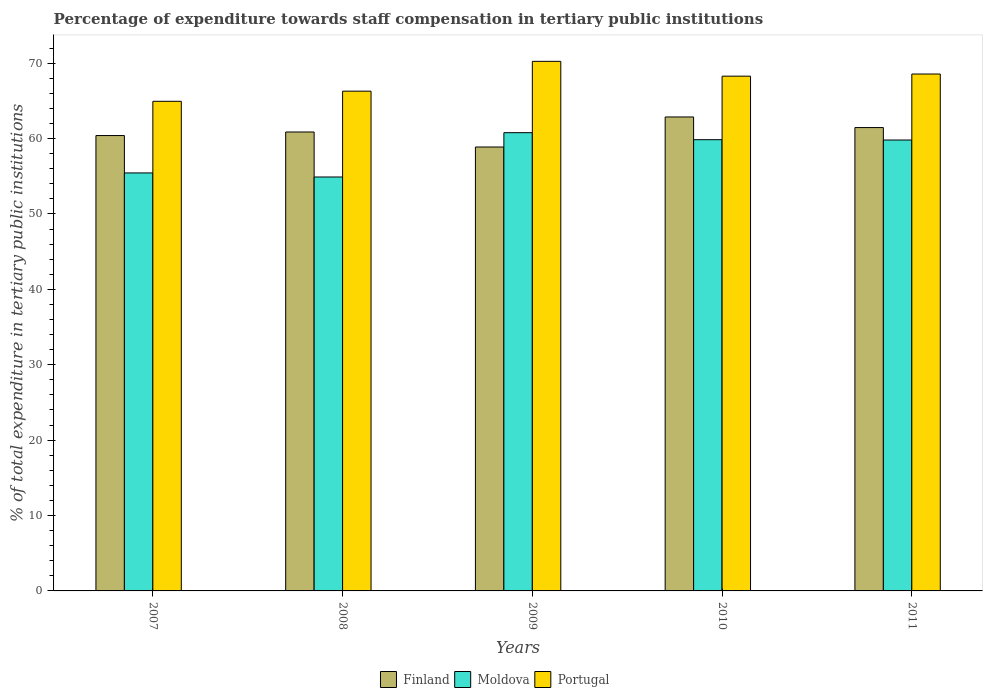How many groups of bars are there?
Offer a very short reply. 5. Are the number of bars on each tick of the X-axis equal?
Provide a short and direct response. Yes. How many bars are there on the 5th tick from the left?
Keep it short and to the point. 3. How many bars are there on the 3rd tick from the right?
Your response must be concise. 3. What is the percentage of expenditure towards staff compensation in Moldova in 2008?
Your response must be concise. 54.9. Across all years, what is the maximum percentage of expenditure towards staff compensation in Portugal?
Provide a short and direct response. 70.24. Across all years, what is the minimum percentage of expenditure towards staff compensation in Moldova?
Keep it short and to the point. 54.9. In which year was the percentage of expenditure towards staff compensation in Moldova maximum?
Your answer should be compact. 2009. In which year was the percentage of expenditure towards staff compensation in Finland minimum?
Keep it short and to the point. 2009. What is the total percentage of expenditure towards staff compensation in Moldova in the graph?
Offer a terse response. 290.76. What is the difference between the percentage of expenditure towards staff compensation in Portugal in 2008 and that in 2009?
Your response must be concise. -3.95. What is the difference between the percentage of expenditure towards staff compensation in Finland in 2008 and the percentage of expenditure towards staff compensation in Moldova in 2011?
Provide a succinct answer. 1.07. What is the average percentage of expenditure towards staff compensation in Finland per year?
Your answer should be compact. 60.89. In the year 2010, what is the difference between the percentage of expenditure towards staff compensation in Finland and percentage of expenditure towards staff compensation in Moldova?
Ensure brevity in your answer.  3.01. What is the ratio of the percentage of expenditure towards staff compensation in Finland in 2007 to that in 2008?
Provide a short and direct response. 0.99. What is the difference between the highest and the second highest percentage of expenditure towards staff compensation in Moldova?
Keep it short and to the point. 0.93. What is the difference between the highest and the lowest percentage of expenditure towards staff compensation in Portugal?
Offer a very short reply. 5.3. In how many years, is the percentage of expenditure towards staff compensation in Finland greater than the average percentage of expenditure towards staff compensation in Finland taken over all years?
Offer a very short reply. 2. Is the sum of the percentage of expenditure towards staff compensation in Moldova in 2008 and 2011 greater than the maximum percentage of expenditure towards staff compensation in Finland across all years?
Offer a very short reply. Yes. What does the 1st bar from the left in 2007 represents?
Your answer should be very brief. Finland. What does the 2nd bar from the right in 2011 represents?
Offer a very short reply. Moldova. How many bars are there?
Ensure brevity in your answer.  15. Are the values on the major ticks of Y-axis written in scientific E-notation?
Your answer should be compact. No. Does the graph contain any zero values?
Keep it short and to the point. No. Does the graph contain grids?
Your answer should be very brief. No. Where does the legend appear in the graph?
Provide a succinct answer. Bottom center. How many legend labels are there?
Your answer should be very brief. 3. What is the title of the graph?
Your response must be concise. Percentage of expenditure towards staff compensation in tertiary public institutions. What is the label or title of the X-axis?
Provide a short and direct response. Years. What is the label or title of the Y-axis?
Provide a succinct answer. % of total expenditure in tertiary public institutions. What is the % of total expenditure in tertiary public institutions in Finland in 2007?
Provide a short and direct response. 60.39. What is the % of total expenditure in tertiary public institutions of Moldova in 2007?
Your answer should be compact. 55.44. What is the % of total expenditure in tertiary public institutions of Portugal in 2007?
Your response must be concise. 64.94. What is the % of total expenditure in tertiary public institutions of Finland in 2008?
Provide a short and direct response. 60.87. What is the % of total expenditure in tertiary public institutions in Moldova in 2008?
Offer a terse response. 54.9. What is the % of total expenditure in tertiary public institutions of Portugal in 2008?
Provide a short and direct response. 66.28. What is the % of total expenditure in tertiary public institutions in Finland in 2009?
Your response must be concise. 58.88. What is the % of total expenditure in tertiary public institutions of Moldova in 2009?
Your answer should be compact. 60.78. What is the % of total expenditure in tertiary public institutions in Portugal in 2009?
Your answer should be very brief. 70.24. What is the % of total expenditure in tertiary public institutions in Finland in 2010?
Make the answer very short. 62.86. What is the % of total expenditure in tertiary public institutions in Moldova in 2010?
Ensure brevity in your answer.  59.85. What is the % of total expenditure in tertiary public institutions in Portugal in 2010?
Offer a very short reply. 68.27. What is the % of total expenditure in tertiary public institutions of Finland in 2011?
Keep it short and to the point. 61.45. What is the % of total expenditure in tertiary public institutions of Moldova in 2011?
Your response must be concise. 59.8. What is the % of total expenditure in tertiary public institutions of Portugal in 2011?
Offer a terse response. 68.56. Across all years, what is the maximum % of total expenditure in tertiary public institutions in Finland?
Offer a very short reply. 62.86. Across all years, what is the maximum % of total expenditure in tertiary public institutions in Moldova?
Offer a terse response. 60.78. Across all years, what is the maximum % of total expenditure in tertiary public institutions of Portugal?
Make the answer very short. 70.24. Across all years, what is the minimum % of total expenditure in tertiary public institutions in Finland?
Offer a very short reply. 58.88. Across all years, what is the minimum % of total expenditure in tertiary public institutions of Moldova?
Keep it short and to the point. 54.9. Across all years, what is the minimum % of total expenditure in tertiary public institutions in Portugal?
Offer a very short reply. 64.94. What is the total % of total expenditure in tertiary public institutions of Finland in the graph?
Offer a very short reply. 304.45. What is the total % of total expenditure in tertiary public institutions in Moldova in the graph?
Your answer should be compact. 290.76. What is the total % of total expenditure in tertiary public institutions in Portugal in the graph?
Keep it short and to the point. 338.28. What is the difference between the % of total expenditure in tertiary public institutions of Finland in 2007 and that in 2008?
Your response must be concise. -0.47. What is the difference between the % of total expenditure in tertiary public institutions in Moldova in 2007 and that in 2008?
Offer a very short reply. 0.54. What is the difference between the % of total expenditure in tertiary public institutions in Portugal in 2007 and that in 2008?
Your answer should be very brief. -1.35. What is the difference between the % of total expenditure in tertiary public institutions in Finland in 2007 and that in 2009?
Your answer should be compact. 1.52. What is the difference between the % of total expenditure in tertiary public institutions in Moldova in 2007 and that in 2009?
Provide a short and direct response. -5.34. What is the difference between the % of total expenditure in tertiary public institutions of Portugal in 2007 and that in 2009?
Offer a very short reply. -5.3. What is the difference between the % of total expenditure in tertiary public institutions of Finland in 2007 and that in 2010?
Your response must be concise. -2.47. What is the difference between the % of total expenditure in tertiary public institutions of Moldova in 2007 and that in 2010?
Make the answer very short. -4.41. What is the difference between the % of total expenditure in tertiary public institutions in Portugal in 2007 and that in 2010?
Your response must be concise. -3.33. What is the difference between the % of total expenditure in tertiary public institutions in Finland in 2007 and that in 2011?
Offer a terse response. -1.06. What is the difference between the % of total expenditure in tertiary public institutions of Moldova in 2007 and that in 2011?
Your answer should be very brief. -4.36. What is the difference between the % of total expenditure in tertiary public institutions of Portugal in 2007 and that in 2011?
Provide a succinct answer. -3.62. What is the difference between the % of total expenditure in tertiary public institutions of Finland in 2008 and that in 2009?
Your answer should be very brief. 1.99. What is the difference between the % of total expenditure in tertiary public institutions of Moldova in 2008 and that in 2009?
Your answer should be very brief. -5.88. What is the difference between the % of total expenditure in tertiary public institutions in Portugal in 2008 and that in 2009?
Your answer should be very brief. -3.95. What is the difference between the % of total expenditure in tertiary public institutions in Finland in 2008 and that in 2010?
Provide a succinct answer. -1.99. What is the difference between the % of total expenditure in tertiary public institutions of Moldova in 2008 and that in 2010?
Offer a very short reply. -4.95. What is the difference between the % of total expenditure in tertiary public institutions of Portugal in 2008 and that in 2010?
Offer a very short reply. -1.99. What is the difference between the % of total expenditure in tertiary public institutions of Finland in 2008 and that in 2011?
Provide a short and direct response. -0.59. What is the difference between the % of total expenditure in tertiary public institutions of Moldova in 2008 and that in 2011?
Provide a short and direct response. -4.9. What is the difference between the % of total expenditure in tertiary public institutions in Portugal in 2008 and that in 2011?
Provide a succinct answer. -2.27. What is the difference between the % of total expenditure in tertiary public institutions in Finland in 2009 and that in 2010?
Your answer should be compact. -3.98. What is the difference between the % of total expenditure in tertiary public institutions in Moldova in 2009 and that in 2010?
Provide a short and direct response. 0.93. What is the difference between the % of total expenditure in tertiary public institutions of Portugal in 2009 and that in 2010?
Offer a terse response. 1.96. What is the difference between the % of total expenditure in tertiary public institutions of Finland in 2009 and that in 2011?
Provide a short and direct response. -2.58. What is the difference between the % of total expenditure in tertiary public institutions of Moldova in 2009 and that in 2011?
Provide a succinct answer. 0.98. What is the difference between the % of total expenditure in tertiary public institutions of Portugal in 2009 and that in 2011?
Your answer should be very brief. 1.68. What is the difference between the % of total expenditure in tertiary public institutions of Finland in 2010 and that in 2011?
Provide a succinct answer. 1.41. What is the difference between the % of total expenditure in tertiary public institutions in Moldova in 2010 and that in 2011?
Your answer should be compact. 0.04. What is the difference between the % of total expenditure in tertiary public institutions in Portugal in 2010 and that in 2011?
Offer a very short reply. -0.28. What is the difference between the % of total expenditure in tertiary public institutions of Finland in 2007 and the % of total expenditure in tertiary public institutions of Moldova in 2008?
Make the answer very short. 5.5. What is the difference between the % of total expenditure in tertiary public institutions of Finland in 2007 and the % of total expenditure in tertiary public institutions of Portugal in 2008?
Your answer should be compact. -5.89. What is the difference between the % of total expenditure in tertiary public institutions of Moldova in 2007 and the % of total expenditure in tertiary public institutions of Portugal in 2008?
Your answer should be very brief. -10.85. What is the difference between the % of total expenditure in tertiary public institutions of Finland in 2007 and the % of total expenditure in tertiary public institutions of Moldova in 2009?
Give a very brief answer. -0.38. What is the difference between the % of total expenditure in tertiary public institutions of Finland in 2007 and the % of total expenditure in tertiary public institutions of Portugal in 2009?
Your answer should be very brief. -9.84. What is the difference between the % of total expenditure in tertiary public institutions in Moldova in 2007 and the % of total expenditure in tertiary public institutions in Portugal in 2009?
Provide a short and direct response. -14.8. What is the difference between the % of total expenditure in tertiary public institutions of Finland in 2007 and the % of total expenditure in tertiary public institutions of Moldova in 2010?
Offer a very short reply. 0.55. What is the difference between the % of total expenditure in tertiary public institutions of Finland in 2007 and the % of total expenditure in tertiary public institutions of Portugal in 2010?
Offer a terse response. -7.88. What is the difference between the % of total expenditure in tertiary public institutions in Moldova in 2007 and the % of total expenditure in tertiary public institutions in Portugal in 2010?
Your answer should be compact. -12.83. What is the difference between the % of total expenditure in tertiary public institutions of Finland in 2007 and the % of total expenditure in tertiary public institutions of Moldova in 2011?
Provide a succinct answer. 0.59. What is the difference between the % of total expenditure in tertiary public institutions in Finland in 2007 and the % of total expenditure in tertiary public institutions in Portugal in 2011?
Give a very brief answer. -8.16. What is the difference between the % of total expenditure in tertiary public institutions of Moldova in 2007 and the % of total expenditure in tertiary public institutions of Portugal in 2011?
Provide a short and direct response. -13.12. What is the difference between the % of total expenditure in tertiary public institutions in Finland in 2008 and the % of total expenditure in tertiary public institutions in Moldova in 2009?
Make the answer very short. 0.09. What is the difference between the % of total expenditure in tertiary public institutions in Finland in 2008 and the % of total expenditure in tertiary public institutions in Portugal in 2009?
Make the answer very short. -9.37. What is the difference between the % of total expenditure in tertiary public institutions of Moldova in 2008 and the % of total expenditure in tertiary public institutions of Portugal in 2009?
Make the answer very short. -15.34. What is the difference between the % of total expenditure in tertiary public institutions of Finland in 2008 and the % of total expenditure in tertiary public institutions of Moldova in 2010?
Your answer should be very brief. 1.02. What is the difference between the % of total expenditure in tertiary public institutions of Finland in 2008 and the % of total expenditure in tertiary public institutions of Portugal in 2010?
Provide a short and direct response. -7.4. What is the difference between the % of total expenditure in tertiary public institutions in Moldova in 2008 and the % of total expenditure in tertiary public institutions in Portugal in 2010?
Provide a short and direct response. -13.37. What is the difference between the % of total expenditure in tertiary public institutions in Finland in 2008 and the % of total expenditure in tertiary public institutions in Moldova in 2011?
Make the answer very short. 1.07. What is the difference between the % of total expenditure in tertiary public institutions of Finland in 2008 and the % of total expenditure in tertiary public institutions of Portugal in 2011?
Your response must be concise. -7.69. What is the difference between the % of total expenditure in tertiary public institutions in Moldova in 2008 and the % of total expenditure in tertiary public institutions in Portugal in 2011?
Keep it short and to the point. -13.66. What is the difference between the % of total expenditure in tertiary public institutions of Finland in 2009 and the % of total expenditure in tertiary public institutions of Moldova in 2010?
Offer a terse response. -0.97. What is the difference between the % of total expenditure in tertiary public institutions of Finland in 2009 and the % of total expenditure in tertiary public institutions of Portugal in 2010?
Ensure brevity in your answer.  -9.4. What is the difference between the % of total expenditure in tertiary public institutions of Moldova in 2009 and the % of total expenditure in tertiary public institutions of Portugal in 2010?
Your response must be concise. -7.49. What is the difference between the % of total expenditure in tertiary public institutions in Finland in 2009 and the % of total expenditure in tertiary public institutions in Moldova in 2011?
Give a very brief answer. -0.92. What is the difference between the % of total expenditure in tertiary public institutions in Finland in 2009 and the % of total expenditure in tertiary public institutions in Portugal in 2011?
Keep it short and to the point. -9.68. What is the difference between the % of total expenditure in tertiary public institutions of Moldova in 2009 and the % of total expenditure in tertiary public institutions of Portugal in 2011?
Your answer should be compact. -7.78. What is the difference between the % of total expenditure in tertiary public institutions in Finland in 2010 and the % of total expenditure in tertiary public institutions in Moldova in 2011?
Offer a very short reply. 3.06. What is the difference between the % of total expenditure in tertiary public institutions in Finland in 2010 and the % of total expenditure in tertiary public institutions in Portugal in 2011?
Offer a terse response. -5.7. What is the difference between the % of total expenditure in tertiary public institutions of Moldova in 2010 and the % of total expenditure in tertiary public institutions of Portugal in 2011?
Your answer should be very brief. -8.71. What is the average % of total expenditure in tertiary public institutions in Finland per year?
Your answer should be compact. 60.89. What is the average % of total expenditure in tertiary public institutions of Moldova per year?
Offer a terse response. 58.15. What is the average % of total expenditure in tertiary public institutions of Portugal per year?
Keep it short and to the point. 67.66. In the year 2007, what is the difference between the % of total expenditure in tertiary public institutions in Finland and % of total expenditure in tertiary public institutions in Moldova?
Ensure brevity in your answer.  4.96. In the year 2007, what is the difference between the % of total expenditure in tertiary public institutions in Finland and % of total expenditure in tertiary public institutions in Portugal?
Your response must be concise. -4.54. In the year 2007, what is the difference between the % of total expenditure in tertiary public institutions of Moldova and % of total expenditure in tertiary public institutions of Portugal?
Your answer should be very brief. -9.5. In the year 2008, what is the difference between the % of total expenditure in tertiary public institutions of Finland and % of total expenditure in tertiary public institutions of Moldova?
Your response must be concise. 5.97. In the year 2008, what is the difference between the % of total expenditure in tertiary public institutions of Finland and % of total expenditure in tertiary public institutions of Portugal?
Your response must be concise. -5.42. In the year 2008, what is the difference between the % of total expenditure in tertiary public institutions in Moldova and % of total expenditure in tertiary public institutions in Portugal?
Your answer should be compact. -11.38. In the year 2009, what is the difference between the % of total expenditure in tertiary public institutions in Finland and % of total expenditure in tertiary public institutions in Moldova?
Your response must be concise. -1.9. In the year 2009, what is the difference between the % of total expenditure in tertiary public institutions of Finland and % of total expenditure in tertiary public institutions of Portugal?
Make the answer very short. -11.36. In the year 2009, what is the difference between the % of total expenditure in tertiary public institutions in Moldova and % of total expenditure in tertiary public institutions in Portugal?
Your answer should be very brief. -9.46. In the year 2010, what is the difference between the % of total expenditure in tertiary public institutions of Finland and % of total expenditure in tertiary public institutions of Moldova?
Give a very brief answer. 3.01. In the year 2010, what is the difference between the % of total expenditure in tertiary public institutions in Finland and % of total expenditure in tertiary public institutions in Portugal?
Your answer should be compact. -5.41. In the year 2010, what is the difference between the % of total expenditure in tertiary public institutions of Moldova and % of total expenditure in tertiary public institutions of Portugal?
Your answer should be compact. -8.43. In the year 2011, what is the difference between the % of total expenditure in tertiary public institutions in Finland and % of total expenditure in tertiary public institutions in Moldova?
Give a very brief answer. 1.65. In the year 2011, what is the difference between the % of total expenditure in tertiary public institutions of Finland and % of total expenditure in tertiary public institutions of Portugal?
Provide a succinct answer. -7.1. In the year 2011, what is the difference between the % of total expenditure in tertiary public institutions of Moldova and % of total expenditure in tertiary public institutions of Portugal?
Keep it short and to the point. -8.75. What is the ratio of the % of total expenditure in tertiary public institutions of Finland in 2007 to that in 2008?
Keep it short and to the point. 0.99. What is the ratio of the % of total expenditure in tertiary public institutions of Moldova in 2007 to that in 2008?
Offer a very short reply. 1.01. What is the ratio of the % of total expenditure in tertiary public institutions of Portugal in 2007 to that in 2008?
Your answer should be very brief. 0.98. What is the ratio of the % of total expenditure in tertiary public institutions of Finland in 2007 to that in 2009?
Ensure brevity in your answer.  1.03. What is the ratio of the % of total expenditure in tertiary public institutions in Moldova in 2007 to that in 2009?
Your answer should be very brief. 0.91. What is the ratio of the % of total expenditure in tertiary public institutions of Portugal in 2007 to that in 2009?
Your answer should be compact. 0.92. What is the ratio of the % of total expenditure in tertiary public institutions in Finland in 2007 to that in 2010?
Provide a succinct answer. 0.96. What is the ratio of the % of total expenditure in tertiary public institutions in Moldova in 2007 to that in 2010?
Keep it short and to the point. 0.93. What is the ratio of the % of total expenditure in tertiary public institutions of Portugal in 2007 to that in 2010?
Your answer should be very brief. 0.95. What is the ratio of the % of total expenditure in tertiary public institutions of Finland in 2007 to that in 2011?
Your answer should be very brief. 0.98. What is the ratio of the % of total expenditure in tertiary public institutions in Moldova in 2007 to that in 2011?
Offer a very short reply. 0.93. What is the ratio of the % of total expenditure in tertiary public institutions in Portugal in 2007 to that in 2011?
Ensure brevity in your answer.  0.95. What is the ratio of the % of total expenditure in tertiary public institutions of Finland in 2008 to that in 2009?
Provide a short and direct response. 1.03. What is the ratio of the % of total expenditure in tertiary public institutions in Moldova in 2008 to that in 2009?
Make the answer very short. 0.9. What is the ratio of the % of total expenditure in tertiary public institutions in Portugal in 2008 to that in 2009?
Offer a terse response. 0.94. What is the ratio of the % of total expenditure in tertiary public institutions of Finland in 2008 to that in 2010?
Make the answer very short. 0.97. What is the ratio of the % of total expenditure in tertiary public institutions in Moldova in 2008 to that in 2010?
Ensure brevity in your answer.  0.92. What is the ratio of the % of total expenditure in tertiary public institutions of Portugal in 2008 to that in 2010?
Provide a short and direct response. 0.97. What is the ratio of the % of total expenditure in tertiary public institutions in Moldova in 2008 to that in 2011?
Ensure brevity in your answer.  0.92. What is the ratio of the % of total expenditure in tertiary public institutions of Portugal in 2008 to that in 2011?
Keep it short and to the point. 0.97. What is the ratio of the % of total expenditure in tertiary public institutions of Finland in 2009 to that in 2010?
Provide a short and direct response. 0.94. What is the ratio of the % of total expenditure in tertiary public institutions in Moldova in 2009 to that in 2010?
Give a very brief answer. 1.02. What is the ratio of the % of total expenditure in tertiary public institutions in Portugal in 2009 to that in 2010?
Your response must be concise. 1.03. What is the ratio of the % of total expenditure in tertiary public institutions of Finland in 2009 to that in 2011?
Provide a short and direct response. 0.96. What is the ratio of the % of total expenditure in tertiary public institutions of Moldova in 2009 to that in 2011?
Ensure brevity in your answer.  1.02. What is the ratio of the % of total expenditure in tertiary public institutions in Portugal in 2009 to that in 2011?
Ensure brevity in your answer.  1.02. What is the ratio of the % of total expenditure in tertiary public institutions in Finland in 2010 to that in 2011?
Make the answer very short. 1.02. What is the ratio of the % of total expenditure in tertiary public institutions in Moldova in 2010 to that in 2011?
Make the answer very short. 1. What is the difference between the highest and the second highest % of total expenditure in tertiary public institutions of Finland?
Your answer should be very brief. 1.41. What is the difference between the highest and the second highest % of total expenditure in tertiary public institutions in Moldova?
Ensure brevity in your answer.  0.93. What is the difference between the highest and the second highest % of total expenditure in tertiary public institutions in Portugal?
Make the answer very short. 1.68. What is the difference between the highest and the lowest % of total expenditure in tertiary public institutions in Finland?
Offer a very short reply. 3.98. What is the difference between the highest and the lowest % of total expenditure in tertiary public institutions in Moldova?
Offer a terse response. 5.88. What is the difference between the highest and the lowest % of total expenditure in tertiary public institutions of Portugal?
Give a very brief answer. 5.3. 